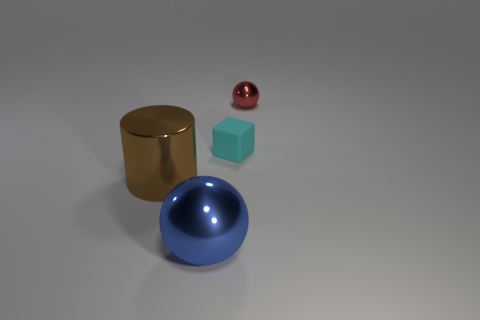What size is the blue thing?
Make the answer very short. Large. What shape is the metallic object that is behind the big sphere and on the left side of the red ball?
Give a very brief answer. Cylinder. The other shiny object that is the same shape as the blue metallic object is what color?
Give a very brief answer. Red. How many objects are objects in front of the tiny red metal sphere or spheres behind the brown object?
Your answer should be compact. 4. What shape is the tiny cyan object?
Keep it short and to the point. Cube. What number of cyan objects are the same material as the cyan block?
Make the answer very short. 0. What is the color of the small ball?
Your response must be concise. Red. What is the color of the ball that is the same size as the brown shiny thing?
Your answer should be compact. Blue. Is the shape of the metal object on the right side of the matte object the same as the big shiny object that is in front of the brown object?
Your answer should be compact. Yes. How many other objects are the same size as the brown metallic thing?
Provide a succinct answer. 1. 